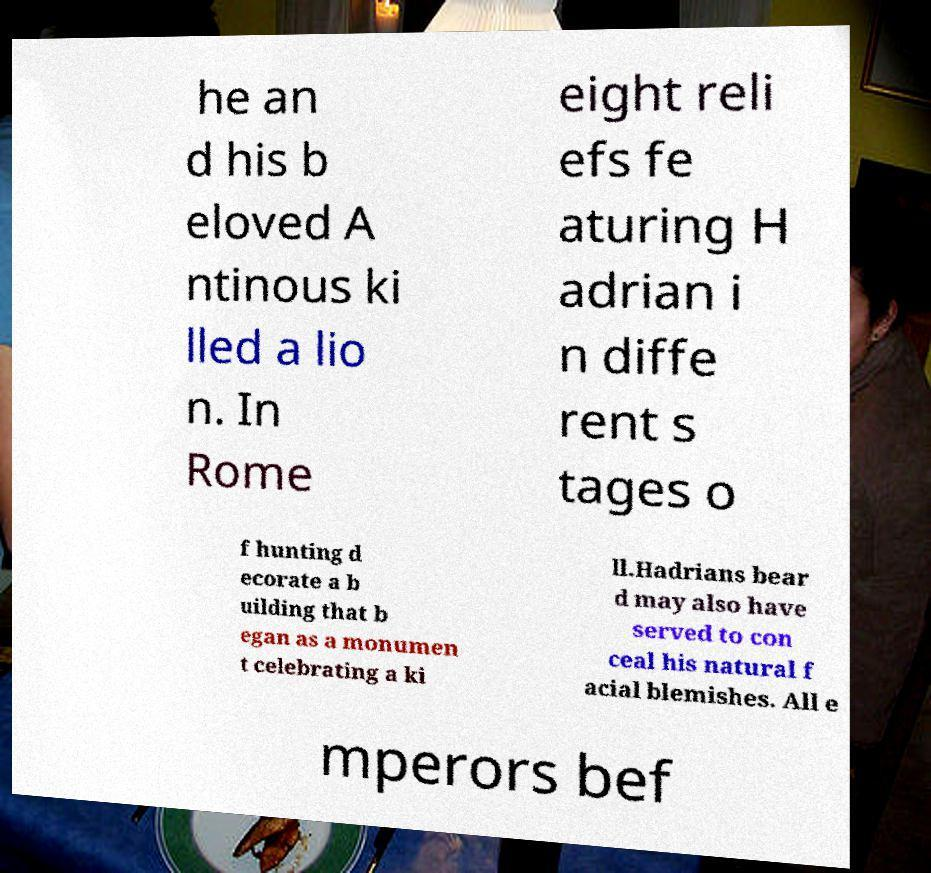There's text embedded in this image that I need extracted. Can you transcribe it verbatim? he an d his b eloved A ntinous ki lled a lio n. In Rome eight reli efs fe aturing H adrian i n diffe rent s tages o f hunting d ecorate a b uilding that b egan as a monumen t celebrating a ki ll.Hadrians bear d may also have served to con ceal his natural f acial blemishes. All e mperors bef 